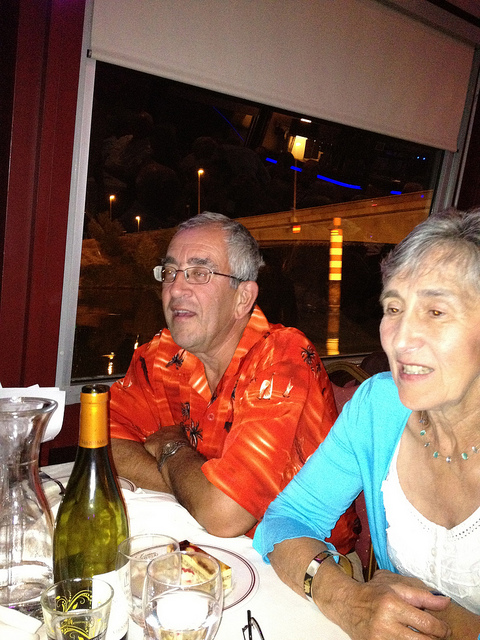Please provide the bounding box coordinate of the region this sentence describes: an older gentleman with gray hair and glasses wearing an orange hawaiian shirt. The bounding box coordinates for the region describing the older gentleman with gray hair and glasses, wearing an orange Hawaiian shirt are approximately [0.29, 0.32, 0.66, 0.85]. 